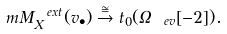Convert formula to latex. <formula><loc_0><loc_0><loc_500><loc_500>\ m M _ { X } ^ { \ e x t } ( v _ { \bullet } ) \stackrel { \cong } { \to } t _ { 0 } ( \Omega _ { \ e v } [ - 2 ] ) .</formula> 